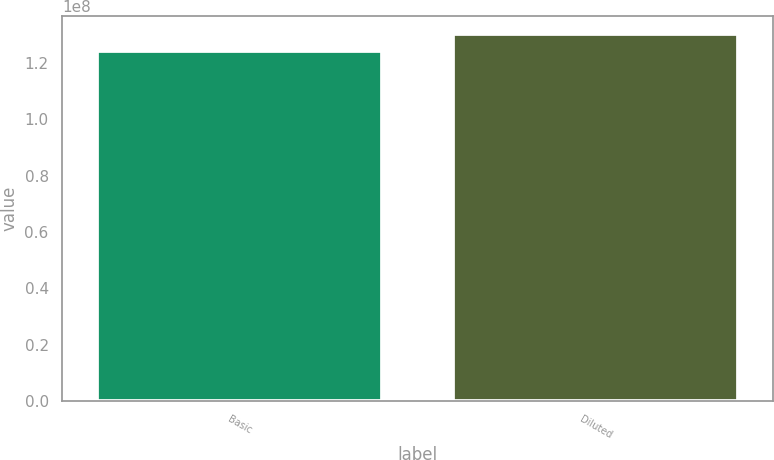Convert chart. <chart><loc_0><loc_0><loc_500><loc_500><bar_chart><fcel>Basic<fcel>Diluted<nl><fcel>1.2404e+08<fcel>1.30189e+08<nl></chart> 